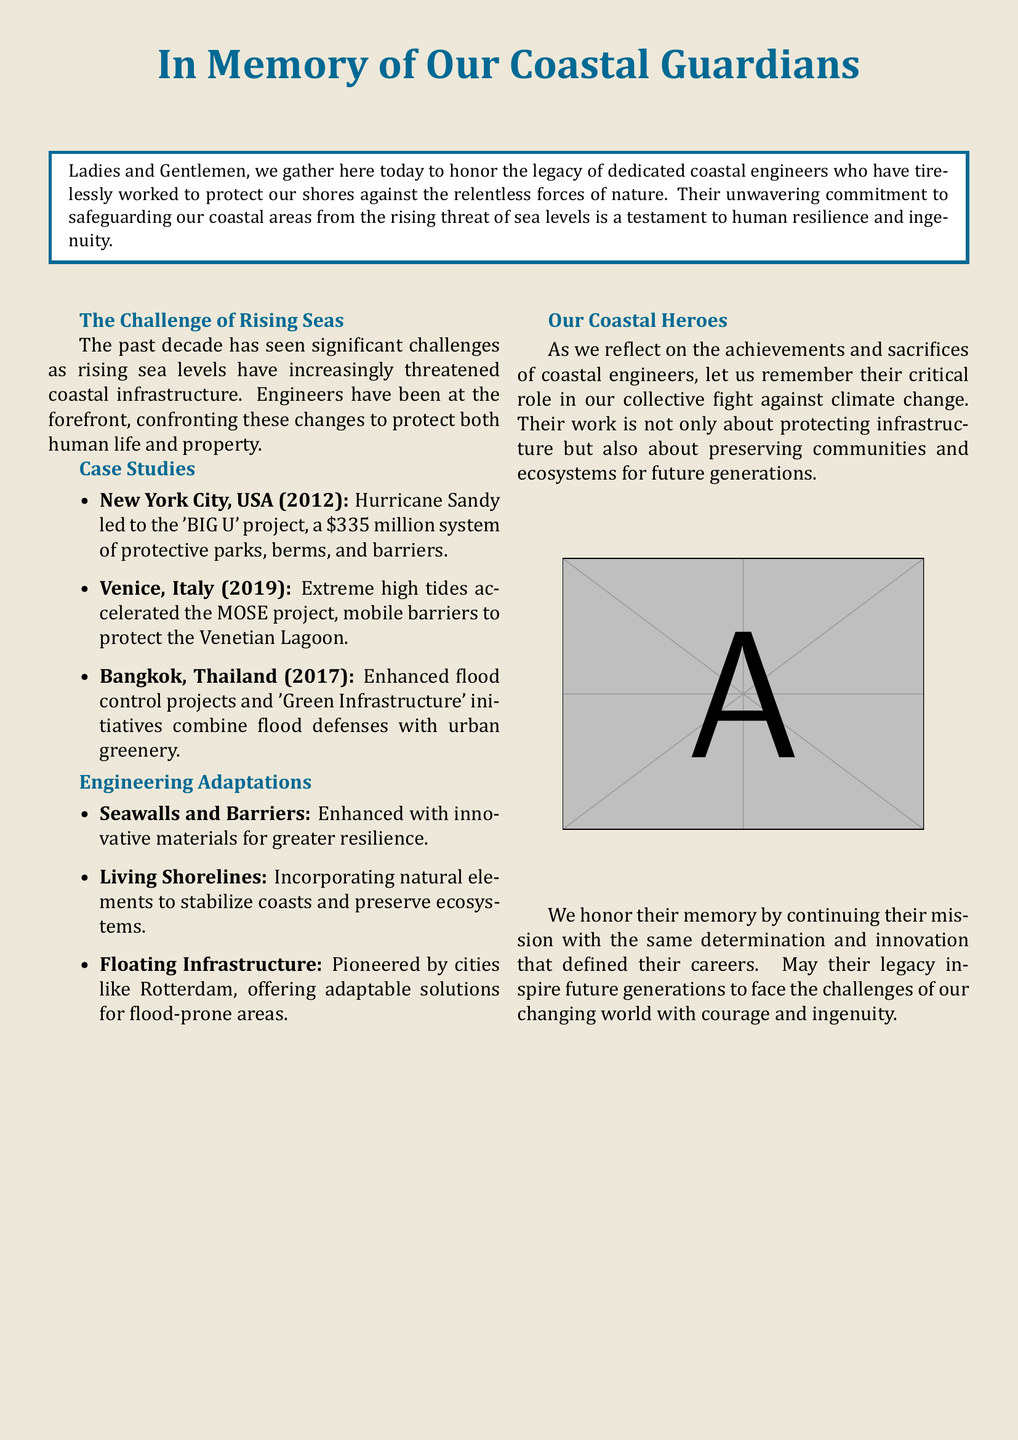What project was initiated after Hurricane Sandy? The project initiated after Hurricane Sandy is described as the 'BIG U' project, aimed at protecting New York City.
Answer: 'BIG U' project Which country implemented the MOSE project? The MOSE project is implemented in Venice, Italy, designed to protect the Venetian Lagoon from extreme high tides.
Answer: Italy What innovative solution is being pioneered by cities like Rotterdam? The text mentions 'Floating Infrastructure' as an innovative solution pioneered by cities like Rotterdam for flood-prone areas.
Answer: Floating Infrastructure In what year did Bangkok enhance its flood control projects? Bangkok enhanced its flood control projects in 2017, as indicated in the document.
Answer: 2017 What type of infrastructure involves natural elements to stabilize coasts? The document refers to 'Living Shorelines' as the type of infrastructure that incorporates natural elements for stabilization.
Answer: Living Shorelines Who are being honored in the eulogy? The eulogy honors dedicated coastal engineers who worked to protect coastal areas from rising sea levels.
Answer: Coastal engineers What financial investment was made for New York City's 'BIG U' project? The financial investment mentioned for the 'BIG U' project was $335 million.
Answer: $335 million What is the primary theme of this eulogy? The primary theme of the eulogy is the dedication of coastal engineers in protecting infrastructure and communities from climate challenges.
Answer: Dedication of coastal engineers 